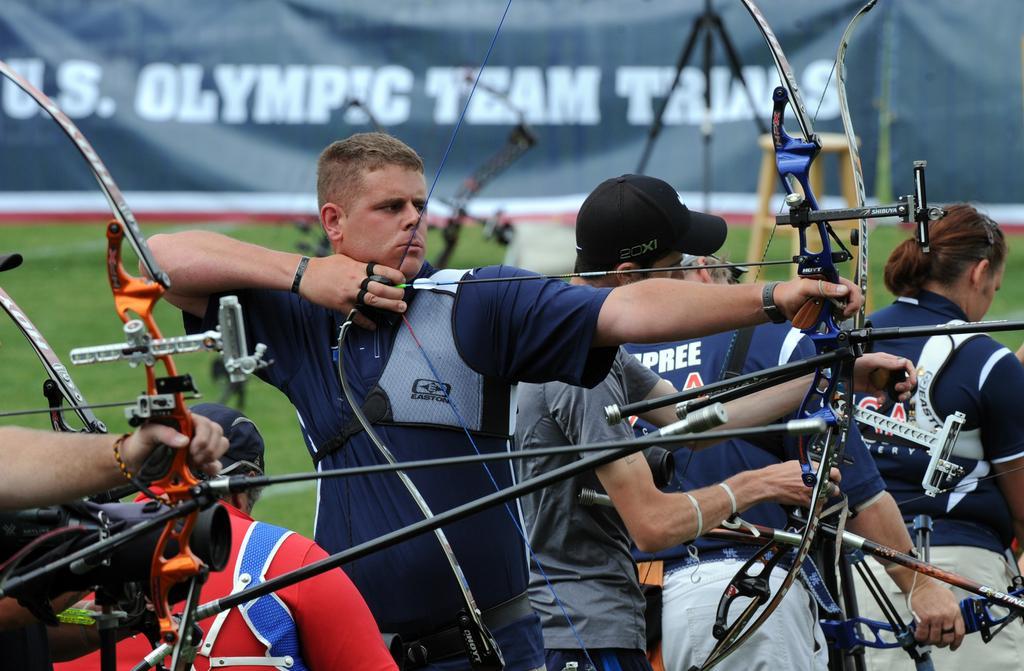Describe this image in one or two sentences. In this image we can see few persons are holding bows, arrows and a person on the right side is sanding. In the background we can see a banner, grass and a tripod stand. 